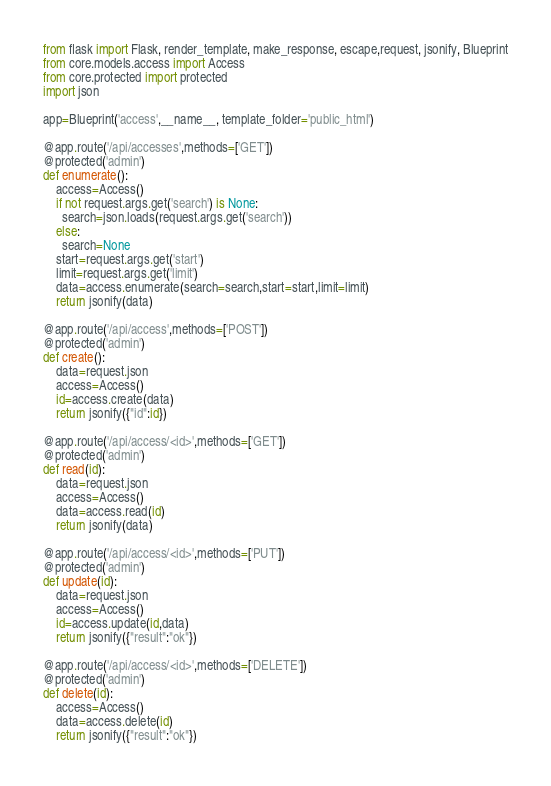<code> <loc_0><loc_0><loc_500><loc_500><_Python_>from flask import Flask, render_template, make_response, escape,request, jsonify, Blueprint
from core.models.access import Access
from core.protected import protected
import json

app=Blueprint('access',__name__, template_folder='public_html')

@app.route('/api/accesses',methods=['GET'])
@protected('admin')
def enumerate():
    access=Access()
    if not request.args.get('search') is None:
      search=json.loads(request.args.get('search'))
    else:
      search=None
    start=request.args.get('start')
    limit=request.args.get('limit')
    data=access.enumerate(search=search,start=start,limit=limit)
    return jsonify(data)

@app.route('/api/access',methods=['POST'])
@protected('admin')
def create():
    data=request.json
    access=Access()
    id=access.create(data)
    return jsonify({"id":id})

@app.route('/api/access/<id>',methods=['GET'])
@protected('admin')
def read(id):
    data=request.json
    access=Access()
    data=access.read(id)
    return jsonify(data)

@app.route('/api/access/<id>',methods=['PUT'])
@protected('admin')
def update(id):
    data=request.json
    access=Access()
    id=access.update(id,data)
    return jsonify({"result":"ok"})

@app.route('/api/access/<id>',methods=['DELETE'])
@protected('admin')
def delete(id):
    access=Access()
    data=access.delete(id)
    return jsonify({"result":"ok"})
</code> 